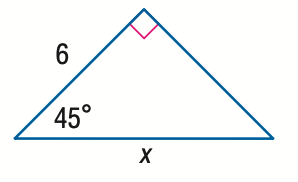Answer the mathemtical geometry problem and directly provide the correct option letter.
Question: Find x.
Choices: A: 6 \sqrt 2 B: 6 \sqrt { 3 } C: 12 D: 6 \sqrt { 6 } A 